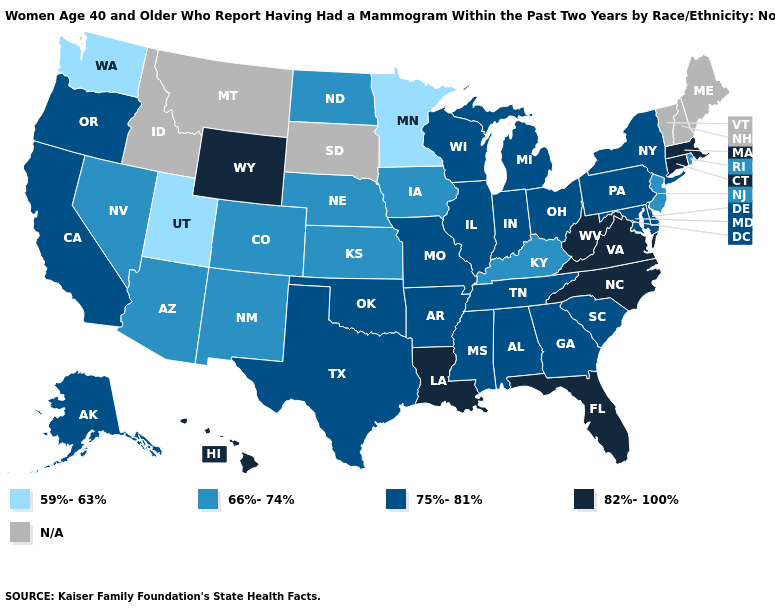Does Iowa have the lowest value in the USA?
Quick response, please. No. What is the highest value in the USA?
Be succinct. 82%-100%. What is the highest value in the USA?
Give a very brief answer. 82%-100%. Which states have the highest value in the USA?
Concise answer only. Connecticut, Florida, Hawaii, Louisiana, Massachusetts, North Carolina, Virginia, West Virginia, Wyoming. What is the lowest value in states that border Massachusetts?
Write a very short answer. 66%-74%. What is the value of Colorado?
Concise answer only. 66%-74%. Which states hav the highest value in the South?
Concise answer only. Florida, Louisiana, North Carolina, Virginia, West Virginia. Name the states that have a value in the range 66%-74%?
Answer briefly. Arizona, Colorado, Iowa, Kansas, Kentucky, Nebraska, Nevada, New Jersey, New Mexico, North Dakota, Rhode Island. What is the value of Rhode Island?
Short answer required. 66%-74%. Which states hav the highest value in the West?
Answer briefly. Hawaii, Wyoming. Does Kentucky have the lowest value in the South?
Give a very brief answer. Yes. What is the lowest value in the USA?
Give a very brief answer. 59%-63%. What is the value of Alaska?
Short answer required. 75%-81%. 